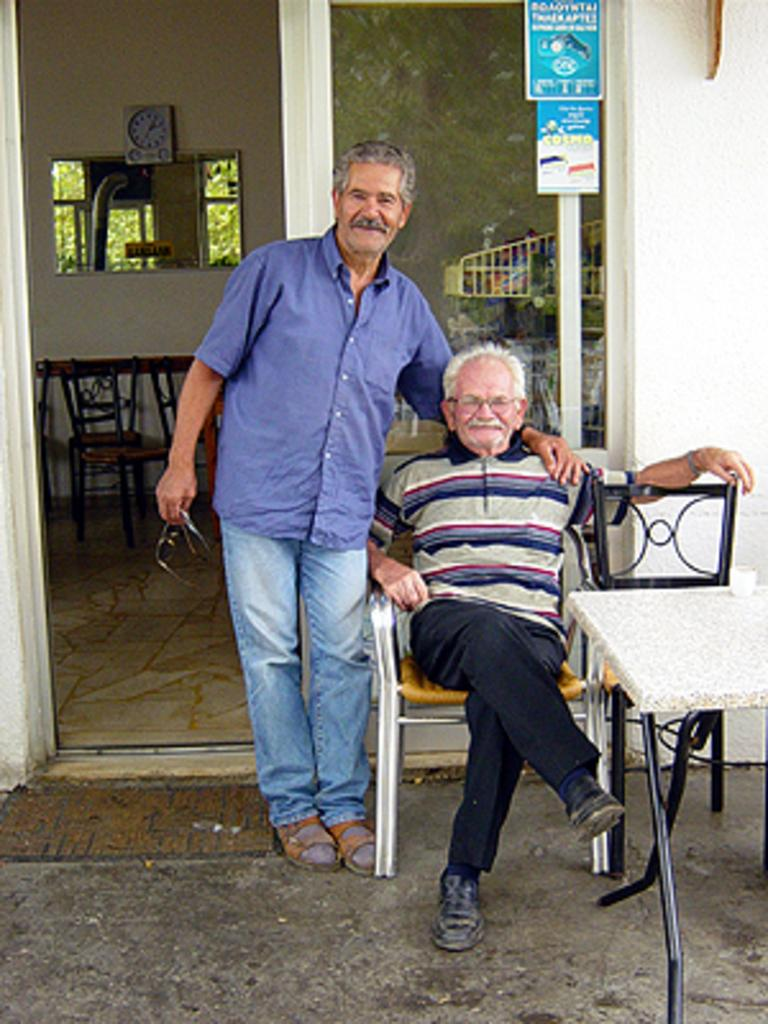How many men are present in the image? There are two men in the image. What is the position of one of the men in the image? One man is seated on a chair. What is the position of the other man in the image? The other man is standing. What type of furniture is present in the image? There are chairs and a table in the image. What is the name of the song that the men are singing in the image? There is no indication in the image that the men are singing or that there is a song playing. 